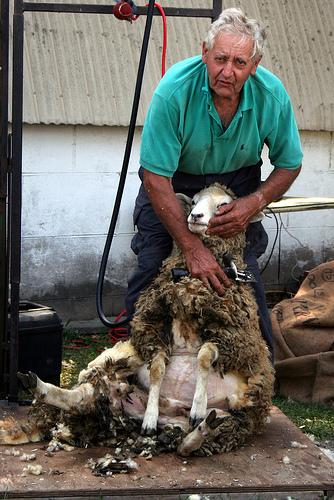Provide information about the sheep's physical appearance during the shearing process. The sheep has a white face with open eyes, a black nose, and its front legs are visible. Its fur appears matted, and its stomach is pinkish. Can you specify the color and style of the shirt the man is wearing? The man is wearing a light blue or turquoise, short sleeve collared shirt with a dark blue emblem. How does the sheep seem to feel during the shearing process? The sheep appears complacent and calm while being sheared by the old man. Assess the image quality based on the details provided in the image. The image quality seems to be high, as numerous details are visible, such as the man's short hair and wristwatch tan line, and the sheep's various physical features. Count the number of visible sheep's legs and describe their appearance as much as possible. Four legs of the sheep are visible, of which two are front legs, and one shows forked toes. They all appear to have hooves. Describe the various objects and elements present around the man and sheep. Some objects include shreds of fur on the table, a thin red wire, a black hose, a burlap sack, grass beside the sheep, and piles of dirty wool. Determine the sentiment conveyed by the image of the man shearing the sheep. The sentiment conveyed is that of calmness and concentration, as the old man carefully shears the sheep, and the sheep appears complacent. Analyze the interactions between the man and the sheep in the image. The man is closely shaving the sheep's fur, and the sheep is sitting upright on the table, appearing to cooperate with the man during the process. What tool is the man using for shearing the sheep, and what is its color? The old man is using shaving shears or a razor in his hand, which is black in color. What is the primary event taking place in the picture? An old man is shearing a sheep sitting on an unpolished wooden table. What are covering the sheep's legs? Hooves with two forked toes Is there a blue bucket filled with water next to the wooden table? No, it's not mentioned in the image. How are the man and the sheep interacting with each other in the image? The man is shearing the sheep while the sheep remains passive. Locate the black hose in the image. Behind the man Describe the scene involving the old man, the sheep, the table, and the objects around them. An old man in a light blue shirt is shearing a complacent sheep on a wooden table. There are shreds of fur on the table and a red wire behind the man. What is the old man doing to the sheep? Shearing the sheep What color is the man's shirt and what is the color of the emblem on it? Light blue or teal with a dark blue emblem Describe the man's facial features. Short grey hair, open eyes, and a black nose Do the eyes of the sheep appear open or closed? Open Analyze the man's face and provide a brief description. The man has short grey hair, open eyes, and a black nose. What activity is the man performing on the sheep? Shaving or shearing Is the sheep lying down or sitting upright? Sitting upright What is the old man holding in his hand? A razor or shaving shears Multiple Choice: What is the color of the shirt worn by the old man?  b) Light blue What are the two main subjects of this image? An old man and a sheep What is seen on the table: a pile of clean laundry or shreds of fur? Shreds of fur In the scene, what interaction is happening between the old man and the sheep? The old man is shearing the sheep Is the table beneath the sheep polished or unpolished? Unpolished Describe the process happening with the sheep and the old man. An old man is shearing a sheep that looks complacent. 